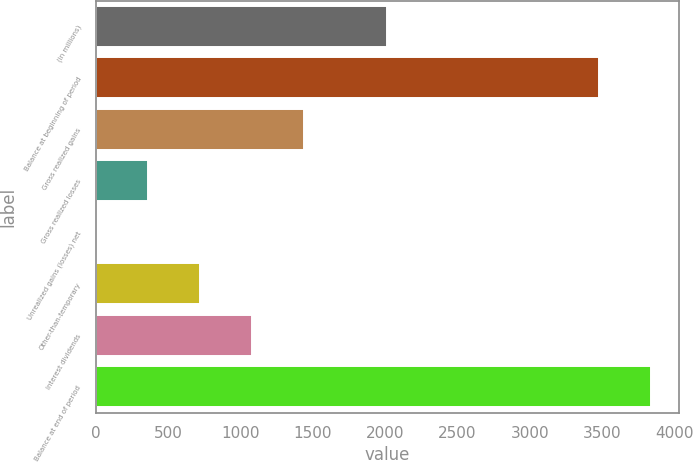Convert chart. <chart><loc_0><loc_0><loc_500><loc_500><bar_chart><fcel>(in millions)<fcel>Balance at beginning of period<fcel>Gross realized gains<fcel>Gross realized losses<fcel>Unrealized gains (losses) net<fcel>Other-than-temporary<fcel>Interest dividends<fcel>Balance at end of period<nl><fcel>2011<fcel>3480<fcel>1441<fcel>365.5<fcel>7<fcel>724<fcel>1082.5<fcel>3838.5<nl></chart> 